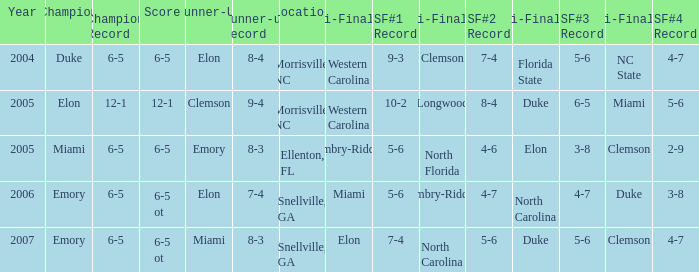Where was the final game played in 2007 Snellville, GA. 